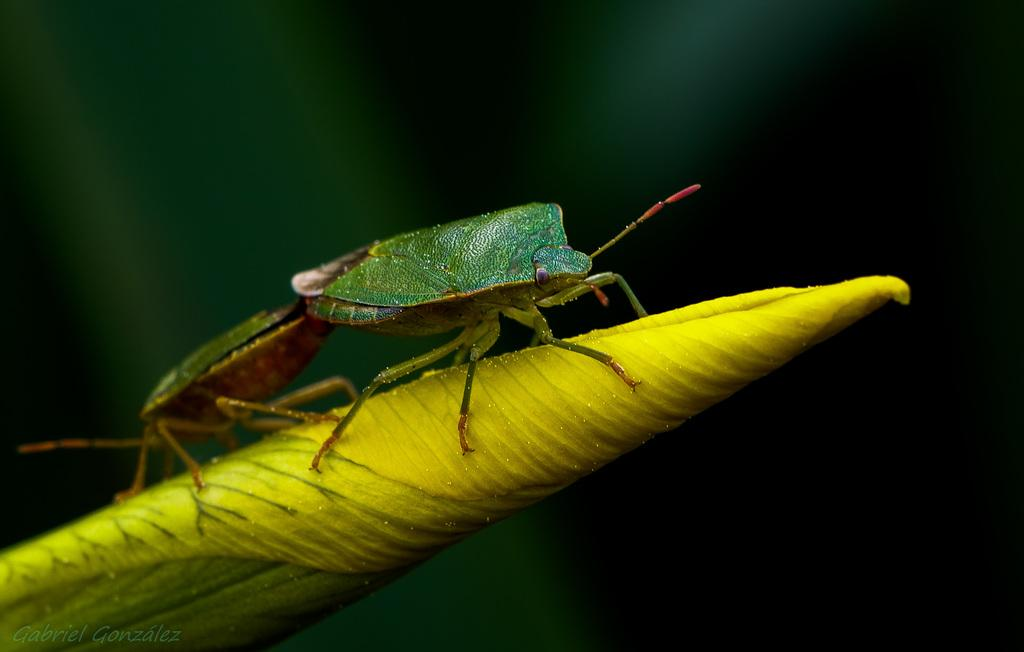What is present on the leaf in the image? There is an insect on the leaf in the image. Can you describe the insect? The insect is green in color. What else can be seen in the image besides the leaf and insect? There is a watermark in the image. How would you describe the overall appearance of the image? The background of the image is dark. What type of doctor is protesting in the image? There is no doctor or protest present in the image; it features a leaf with an insect on it and has a dark background. 